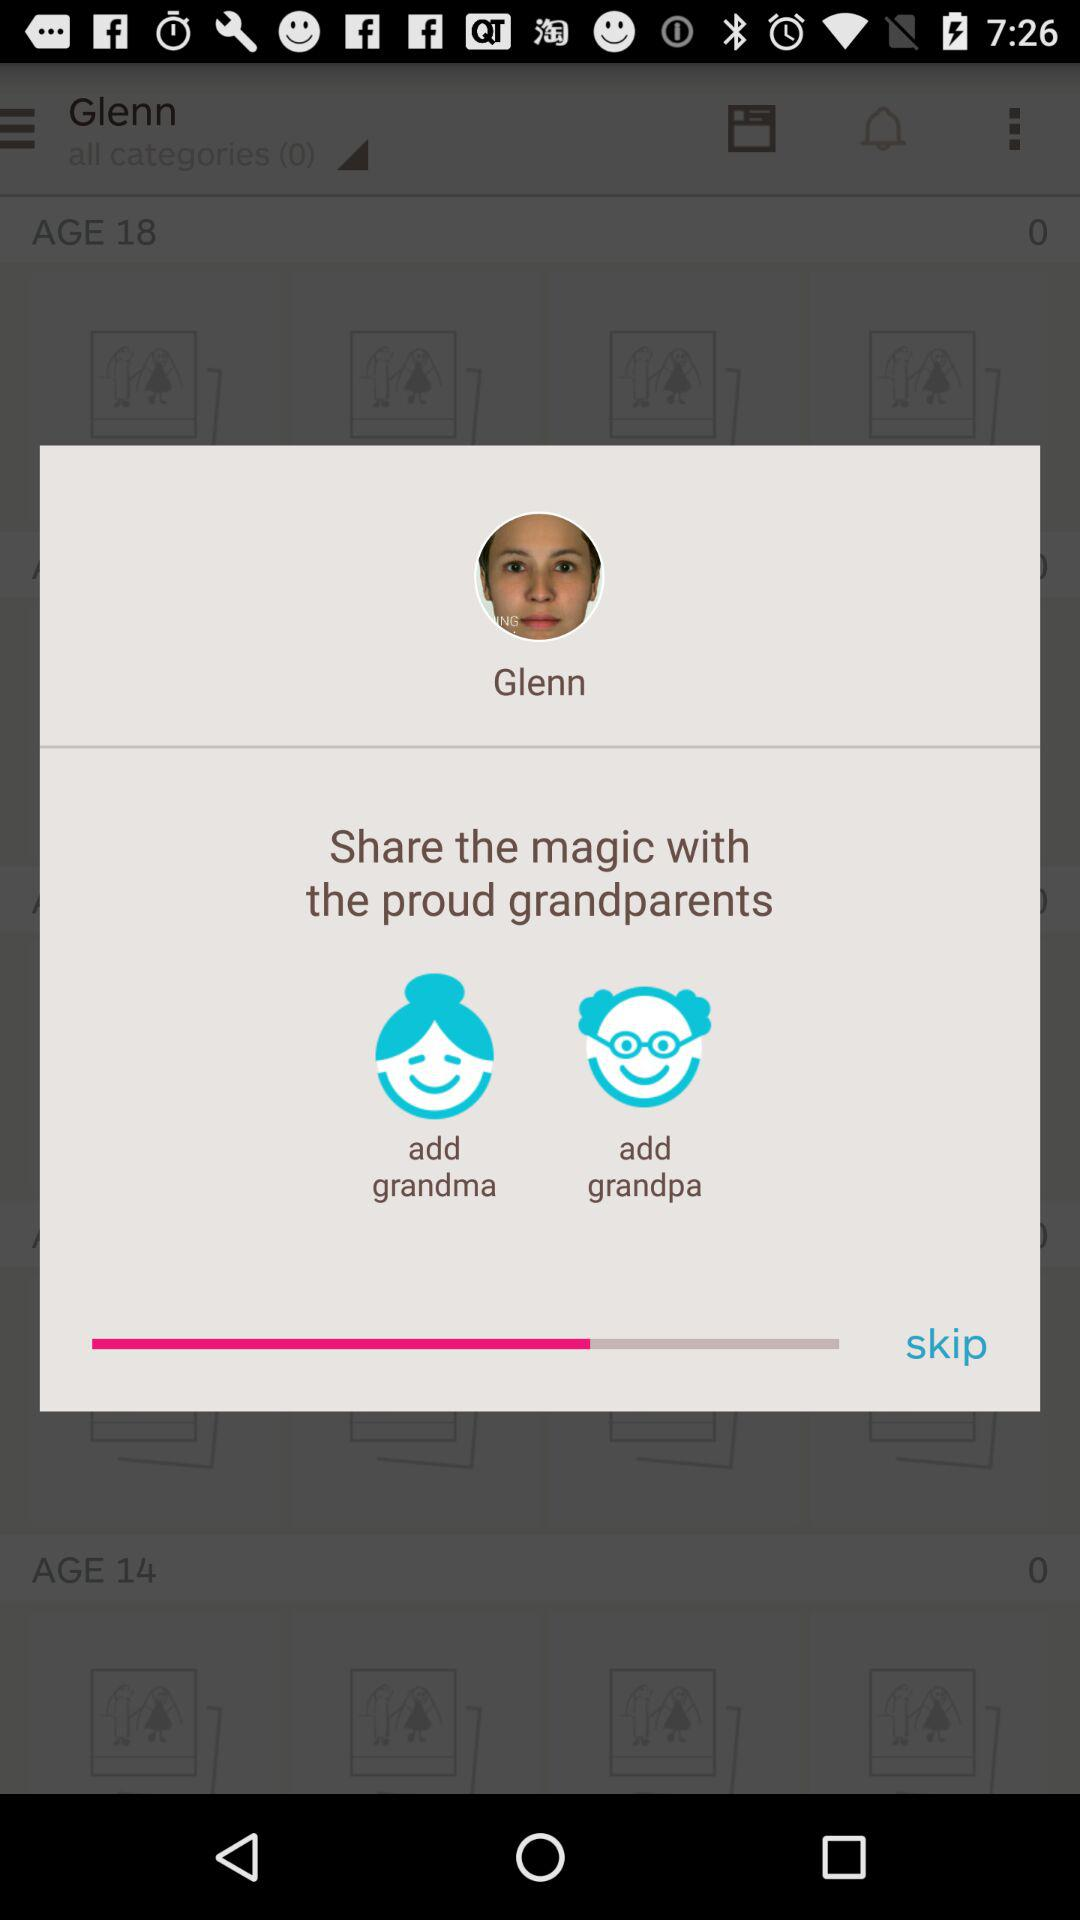What's the total number of persons who are 18 years old? The total number of persons who are 18 years old is 0. 